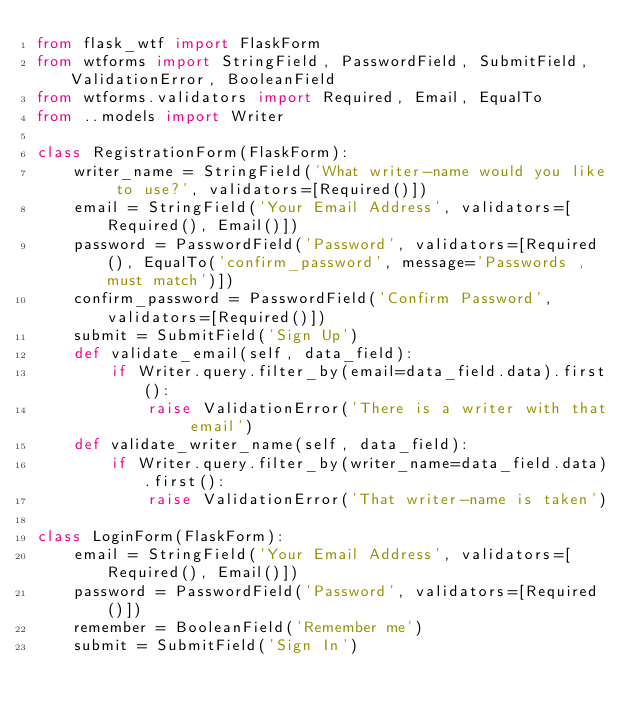<code> <loc_0><loc_0><loc_500><loc_500><_Python_>from flask_wtf import FlaskForm
from wtforms import StringField, PasswordField, SubmitField, ValidationError, BooleanField
from wtforms.validators import Required, Email, EqualTo
from ..models import Writer

class RegistrationForm(FlaskForm):
    writer_name = StringField('What writer-name would you like to use?', validators=[Required()])
    email = StringField('Your Email Address', validators=[Required(), Email()])
    password = PasswordField('Password', validators=[Required(), EqualTo('confirm_password', message='Passwords ,must match')])
    confirm_password = PasswordField('Confirm Password', validators=[Required()])
    submit = SubmitField('Sign Up')
    def validate_email(self, data_field):
        if Writer.query.filter_by(email=data_field.data).first():
            raise ValidationError('There is a writer with that email')
    def validate_writer_name(self, data_field):
        if Writer.query.filter_by(writer_name=data_field.data).first():
            raise ValidationError('That writer-name is taken')

class LoginForm(FlaskForm):
    email = StringField('Your Email Address', validators=[Required(), Email()])
    password = PasswordField('Password', validators=[Required()])
    remember = BooleanField('Remember me')
    submit = SubmitField('Sign In')</code> 